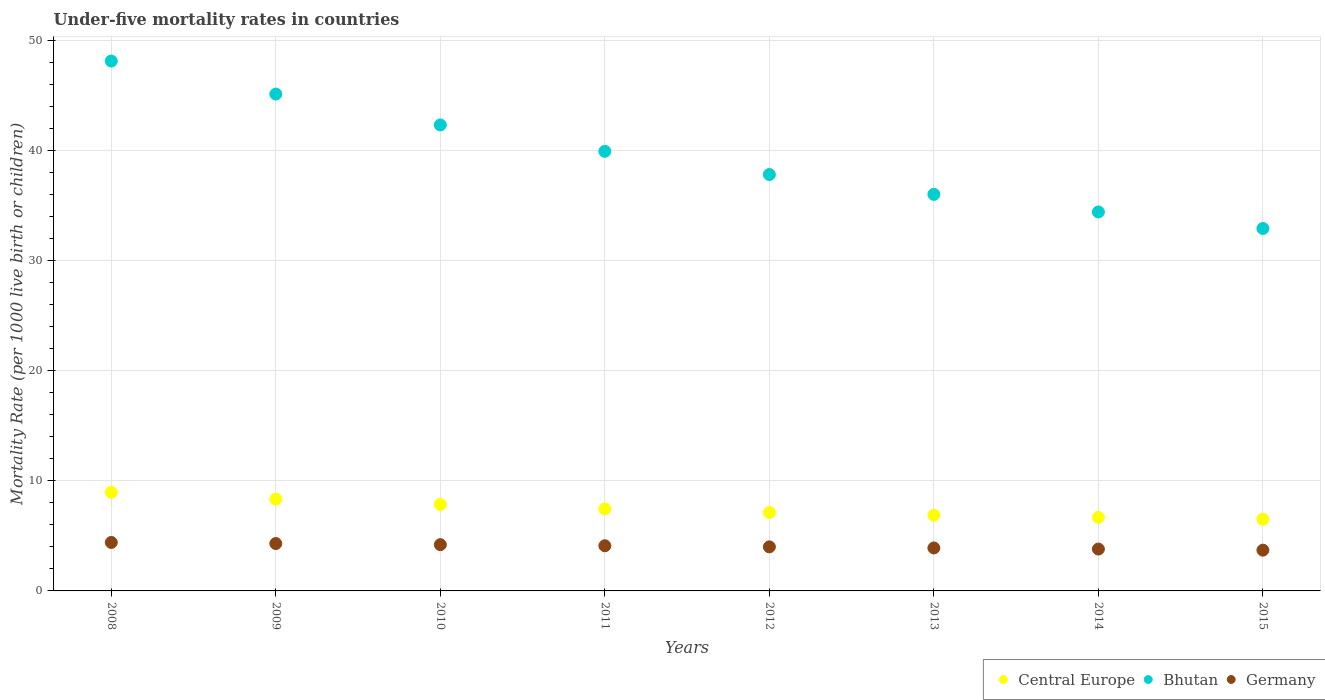Is the number of dotlines equal to the number of legend labels?
Offer a very short reply. Yes. What is the under-five mortality rate in Bhutan in 2012?
Offer a terse response. 37.8. Across all years, what is the maximum under-five mortality rate in Central Europe?
Give a very brief answer. 8.95. Across all years, what is the minimum under-five mortality rate in Central Europe?
Give a very brief answer. 6.51. In which year was the under-five mortality rate in Central Europe minimum?
Ensure brevity in your answer.  2015. What is the total under-five mortality rate in Germany in the graph?
Your response must be concise. 32.4. What is the difference between the under-five mortality rate in Bhutan in 2010 and that in 2014?
Ensure brevity in your answer.  7.9. What is the average under-five mortality rate in Central Europe per year?
Provide a succinct answer. 7.47. In the year 2012, what is the difference between the under-five mortality rate in Central Europe and under-five mortality rate in Bhutan?
Ensure brevity in your answer.  -30.68. In how many years, is the under-five mortality rate in Central Europe greater than 20?
Offer a terse response. 0. What is the ratio of the under-five mortality rate in Central Europe in 2010 to that in 2014?
Your answer should be compact. 1.18. What is the difference between the highest and the lowest under-five mortality rate in Central Europe?
Provide a succinct answer. 2.44. Does the under-five mortality rate in Germany monotonically increase over the years?
Offer a very short reply. No. Is the under-five mortality rate in Bhutan strictly less than the under-five mortality rate in Germany over the years?
Offer a very short reply. No. How many years are there in the graph?
Make the answer very short. 8. Are the values on the major ticks of Y-axis written in scientific E-notation?
Offer a very short reply. No. Does the graph contain any zero values?
Ensure brevity in your answer.  No. Where does the legend appear in the graph?
Your answer should be compact. Bottom right. How many legend labels are there?
Your answer should be compact. 3. What is the title of the graph?
Provide a short and direct response. Under-five mortality rates in countries. What is the label or title of the Y-axis?
Give a very brief answer. Mortality Rate (per 1000 live birth or children). What is the Mortality Rate (per 1000 live birth or children) in Central Europe in 2008?
Offer a very short reply. 8.95. What is the Mortality Rate (per 1000 live birth or children) in Bhutan in 2008?
Provide a succinct answer. 48.1. What is the Mortality Rate (per 1000 live birth or children) in Central Europe in 2009?
Your answer should be compact. 8.34. What is the Mortality Rate (per 1000 live birth or children) of Bhutan in 2009?
Ensure brevity in your answer.  45.1. What is the Mortality Rate (per 1000 live birth or children) in Central Europe in 2010?
Make the answer very short. 7.85. What is the Mortality Rate (per 1000 live birth or children) of Bhutan in 2010?
Offer a very short reply. 42.3. What is the Mortality Rate (per 1000 live birth or children) in Germany in 2010?
Provide a short and direct response. 4.2. What is the Mortality Rate (per 1000 live birth or children) of Central Europe in 2011?
Keep it short and to the point. 7.45. What is the Mortality Rate (per 1000 live birth or children) in Bhutan in 2011?
Provide a succinct answer. 39.9. What is the Mortality Rate (per 1000 live birth or children) in Central Europe in 2012?
Your response must be concise. 7.12. What is the Mortality Rate (per 1000 live birth or children) of Bhutan in 2012?
Offer a very short reply. 37.8. What is the Mortality Rate (per 1000 live birth or children) in Central Europe in 2013?
Provide a succinct answer. 6.88. What is the Mortality Rate (per 1000 live birth or children) in Central Europe in 2014?
Your answer should be very brief. 6.68. What is the Mortality Rate (per 1000 live birth or children) in Bhutan in 2014?
Give a very brief answer. 34.4. What is the Mortality Rate (per 1000 live birth or children) in Central Europe in 2015?
Offer a very short reply. 6.51. What is the Mortality Rate (per 1000 live birth or children) in Bhutan in 2015?
Offer a very short reply. 32.9. What is the Mortality Rate (per 1000 live birth or children) of Germany in 2015?
Ensure brevity in your answer.  3.7. Across all years, what is the maximum Mortality Rate (per 1000 live birth or children) of Central Europe?
Make the answer very short. 8.95. Across all years, what is the maximum Mortality Rate (per 1000 live birth or children) of Bhutan?
Keep it short and to the point. 48.1. Across all years, what is the minimum Mortality Rate (per 1000 live birth or children) in Central Europe?
Make the answer very short. 6.51. Across all years, what is the minimum Mortality Rate (per 1000 live birth or children) in Bhutan?
Offer a very short reply. 32.9. Across all years, what is the minimum Mortality Rate (per 1000 live birth or children) of Germany?
Your answer should be compact. 3.7. What is the total Mortality Rate (per 1000 live birth or children) in Central Europe in the graph?
Ensure brevity in your answer.  59.76. What is the total Mortality Rate (per 1000 live birth or children) of Bhutan in the graph?
Offer a terse response. 316.5. What is the total Mortality Rate (per 1000 live birth or children) of Germany in the graph?
Your response must be concise. 32.4. What is the difference between the Mortality Rate (per 1000 live birth or children) in Central Europe in 2008 and that in 2009?
Keep it short and to the point. 0.61. What is the difference between the Mortality Rate (per 1000 live birth or children) of Bhutan in 2008 and that in 2009?
Keep it short and to the point. 3. What is the difference between the Mortality Rate (per 1000 live birth or children) in Germany in 2008 and that in 2009?
Ensure brevity in your answer.  0.1. What is the difference between the Mortality Rate (per 1000 live birth or children) of Central Europe in 2008 and that in 2010?
Offer a very short reply. 1.1. What is the difference between the Mortality Rate (per 1000 live birth or children) of Bhutan in 2008 and that in 2010?
Provide a short and direct response. 5.8. What is the difference between the Mortality Rate (per 1000 live birth or children) in Germany in 2008 and that in 2010?
Give a very brief answer. 0.2. What is the difference between the Mortality Rate (per 1000 live birth or children) of Central Europe in 2008 and that in 2011?
Provide a short and direct response. 1.5. What is the difference between the Mortality Rate (per 1000 live birth or children) in Bhutan in 2008 and that in 2011?
Give a very brief answer. 8.2. What is the difference between the Mortality Rate (per 1000 live birth or children) of Germany in 2008 and that in 2011?
Offer a very short reply. 0.3. What is the difference between the Mortality Rate (per 1000 live birth or children) in Central Europe in 2008 and that in 2012?
Offer a very short reply. 1.83. What is the difference between the Mortality Rate (per 1000 live birth or children) in Germany in 2008 and that in 2012?
Your response must be concise. 0.4. What is the difference between the Mortality Rate (per 1000 live birth or children) of Central Europe in 2008 and that in 2013?
Offer a terse response. 2.07. What is the difference between the Mortality Rate (per 1000 live birth or children) in Bhutan in 2008 and that in 2013?
Your answer should be very brief. 12.1. What is the difference between the Mortality Rate (per 1000 live birth or children) in Germany in 2008 and that in 2013?
Your answer should be compact. 0.5. What is the difference between the Mortality Rate (per 1000 live birth or children) in Central Europe in 2008 and that in 2014?
Your response must be concise. 2.27. What is the difference between the Mortality Rate (per 1000 live birth or children) in Bhutan in 2008 and that in 2014?
Offer a very short reply. 13.7. What is the difference between the Mortality Rate (per 1000 live birth or children) in Central Europe in 2008 and that in 2015?
Provide a short and direct response. 2.44. What is the difference between the Mortality Rate (per 1000 live birth or children) in Germany in 2008 and that in 2015?
Your answer should be very brief. 0.7. What is the difference between the Mortality Rate (per 1000 live birth or children) in Central Europe in 2009 and that in 2010?
Provide a short and direct response. 0.49. What is the difference between the Mortality Rate (per 1000 live birth or children) of Central Europe in 2009 and that in 2011?
Give a very brief answer. 0.89. What is the difference between the Mortality Rate (per 1000 live birth or children) of Central Europe in 2009 and that in 2012?
Provide a short and direct response. 1.22. What is the difference between the Mortality Rate (per 1000 live birth or children) of Bhutan in 2009 and that in 2012?
Provide a succinct answer. 7.3. What is the difference between the Mortality Rate (per 1000 live birth or children) in Germany in 2009 and that in 2012?
Ensure brevity in your answer.  0.3. What is the difference between the Mortality Rate (per 1000 live birth or children) of Central Europe in 2009 and that in 2013?
Your answer should be very brief. 1.46. What is the difference between the Mortality Rate (per 1000 live birth or children) of Central Europe in 2009 and that in 2014?
Offer a very short reply. 1.66. What is the difference between the Mortality Rate (per 1000 live birth or children) in Bhutan in 2009 and that in 2014?
Offer a very short reply. 10.7. What is the difference between the Mortality Rate (per 1000 live birth or children) of Germany in 2009 and that in 2014?
Offer a terse response. 0.5. What is the difference between the Mortality Rate (per 1000 live birth or children) of Central Europe in 2009 and that in 2015?
Keep it short and to the point. 1.83. What is the difference between the Mortality Rate (per 1000 live birth or children) of Bhutan in 2009 and that in 2015?
Offer a very short reply. 12.2. What is the difference between the Mortality Rate (per 1000 live birth or children) of Germany in 2009 and that in 2015?
Make the answer very short. 0.6. What is the difference between the Mortality Rate (per 1000 live birth or children) of Central Europe in 2010 and that in 2011?
Ensure brevity in your answer.  0.4. What is the difference between the Mortality Rate (per 1000 live birth or children) in Bhutan in 2010 and that in 2011?
Offer a very short reply. 2.4. What is the difference between the Mortality Rate (per 1000 live birth or children) of Germany in 2010 and that in 2011?
Provide a succinct answer. 0.1. What is the difference between the Mortality Rate (per 1000 live birth or children) of Central Europe in 2010 and that in 2012?
Your response must be concise. 0.73. What is the difference between the Mortality Rate (per 1000 live birth or children) in Bhutan in 2010 and that in 2012?
Ensure brevity in your answer.  4.5. What is the difference between the Mortality Rate (per 1000 live birth or children) in Bhutan in 2010 and that in 2013?
Your answer should be very brief. 6.3. What is the difference between the Mortality Rate (per 1000 live birth or children) in Central Europe in 2010 and that in 2014?
Ensure brevity in your answer.  1.17. What is the difference between the Mortality Rate (per 1000 live birth or children) of Central Europe in 2010 and that in 2015?
Your answer should be very brief. 1.34. What is the difference between the Mortality Rate (per 1000 live birth or children) of Bhutan in 2010 and that in 2015?
Give a very brief answer. 9.4. What is the difference between the Mortality Rate (per 1000 live birth or children) in Central Europe in 2011 and that in 2012?
Offer a very short reply. 0.33. What is the difference between the Mortality Rate (per 1000 live birth or children) in Bhutan in 2011 and that in 2012?
Offer a terse response. 2.1. What is the difference between the Mortality Rate (per 1000 live birth or children) in Germany in 2011 and that in 2012?
Offer a terse response. 0.1. What is the difference between the Mortality Rate (per 1000 live birth or children) of Central Europe in 2011 and that in 2013?
Keep it short and to the point. 0.57. What is the difference between the Mortality Rate (per 1000 live birth or children) in Bhutan in 2011 and that in 2013?
Offer a terse response. 3.9. What is the difference between the Mortality Rate (per 1000 live birth or children) in Central Europe in 2011 and that in 2014?
Offer a very short reply. 0.77. What is the difference between the Mortality Rate (per 1000 live birth or children) of Germany in 2011 and that in 2014?
Keep it short and to the point. 0.3. What is the difference between the Mortality Rate (per 1000 live birth or children) in Central Europe in 2011 and that in 2015?
Offer a terse response. 0.94. What is the difference between the Mortality Rate (per 1000 live birth or children) in Germany in 2011 and that in 2015?
Give a very brief answer. 0.4. What is the difference between the Mortality Rate (per 1000 live birth or children) in Central Europe in 2012 and that in 2013?
Provide a short and direct response. 0.24. What is the difference between the Mortality Rate (per 1000 live birth or children) of Bhutan in 2012 and that in 2013?
Make the answer very short. 1.8. What is the difference between the Mortality Rate (per 1000 live birth or children) of Germany in 2012 and that in 2013?
Offer a very short reply. 0.1. What is the difference between the Mortality Rate (per 1000 live birth or children) of Central Europe in 2012 and that in 2014?
Your answer should be compact. 0.44. What is the difference between the Mortality Rate (per 1000 live birth or children) of Germany in 2012 and that in 2014?
Make the answer very short. 0.2. What is the difference between the Mortality Rate (per 1000 live birth or children) in Central Europe in 2012 and that in 2015?
Keep it short and to the point. 0.61. What is the difference between the Mortality Rate (per 1000 live birth or children) of Bhutan in 2012 and that in 2015?
Keep it short and to the point. 4.9. What is the difference between the Mortality Rate (per 1000 live birth or children) of Central Europe in 2013 and that in 2014?
Keep it short and to the point. 0.2. What is the difference between the Mortality Rate (per 1000 live birth or children) of Bhutan in 2013 and that in 2014?
Ensure brevity in your answer.  1.6. What is the difference between the Mortality Rate (per 1000 live birth or children) of Central Europe in 2013 and that in 2015?
Make the answer very short. 0.37. What is the difference between the Mortality Rate (per 1000 live birth or children) in Bhutan in 2013 and that in 2015?
Your answer should be very brief. 3.1. What is the difference between the Mortality Rate (per 1000 live birth or children) of Central Europe in 2014 and that in 2015?
Ensure brevity in your answer.  0.17. What is the difference between the Mortality Rate (per 1000 live birth or children) in Central Europe in 2008 and the Mortality Rate (per 1000 live birth or children) in Bhutan in 2009?
Offer a very short reply. -36.15. What is the difference between the Mortality Rate (per 1000 live birth or children) of Central Europe in 2008 and the Mortality Rate (per 1000 live birth or children) of Germany in 2009?
Ensure brevity in your answer.  4.65. What is the difference between the Mortality Rate (per 1000 live birth or children) of Bhutan in 2008 and the Mortality Rate (per 1000 live birth or children) of Germany in 2009?
Give a very brief answer. 43.8. What is the difference between the Mortality Rate (per 1000 live birth or children) in Central Europe in 2008 and the Mortality Rate (per 1000 live birth or children) in Bhutan in 2010?
Offer a very short reply. -33.35. What is the difference between the Mortality Rate (per 1000 live birth or children) in Central Europe in 2008 and the Mortality Rate (per 1000 live birth or children) in Germany in 2010?
Provide a short and direct response. 4.75. What is the difference between the Mortality Rate (per 1000 live birth or children) of Bhutan in 2008 and the Mortality Rate (per 1000 live birth or children) of Germany in 2010?
Provide a succinct answer. 43.9. What is the difference between the Mortality Rate (per 1000 live birth or children) of Central Europe in 2008 and the Mortality Rate (per 1000 live birth or children) of Bhutan in 2011?
Your answer should be very brief. -30.95. What is the difference between the Mortality Rate (per 1000 live birth or children) in Central Europe in 2008 and the Mortality Rate (per 1000 live birth or children) in Germany in 2011?
Ensure brevity in your answer.  4.85. What is the difference between the Mortality Rate (per 1000 live birth or children) in Bhutan in 2008 and the Mortality Rate (per 1000 live birth or children) in Germany in 2011?
Your response must be concise. 44. What is the difference between the Mortality Rate (per 1000 live birth or children) of Central Europe in 2008 and the Mortality Rate (per 1000 live birth or children) of Bhutan in 2012?
Give a very brief answer. -28.85. What is the difference between the Mortality Rate (per 1000 live birth or children) in Central Europe in 2008 and the Mortality Rate (per 1000 live birth or children) in Germany in 2012?
Provide a short and direct response. 4.95. What is the difference between the Mortality Rate (per 1000 live birth or children) of Bhutan in 2008 and the Mortality Rate (per 1000 live birth or children) of Germany in 2012?
Make the answer very short. 44.1. What is the difference between the Mortality Rate (per 1000 live birth or children) in Central Europe in 2008 and the Mortality Rate (per 1000 live birth or children) in Bhutan in 2013?
Provide a short and direct response. -27.05. What is the difference between the Mortality Rate (per 1000 live birth or children) in Central Europe in 2008 and the Mortality Rate (per 1000 live birth or children) in Germany in 2013?
Your answer should be compact. 5.05. What is the difference between the Mortality Rate (per 1000 live birth or children) in Bhutan in 2008 and the Mortality Rate (per 1000 live birth or children) in Germany in 2013?
Your answer should be very brief. 44.2. What is the difference between the Mortality Rate (per 1000 live birth or children) of Central Europe in 2008 and the Mortality Rate (per 1000 live birth or children) of Bhutan in 2014?
Offer a terse response. -25.45. What is the difference between the Mortality Rate (per 1000 live birth or children) of Central Europe in 2008 and the Mortality Rate (per 1000 live birth or children) of Germany in 2014?
Your answer should be compact. 5.15. What is the difference between the Mortality Rate (per 1000 live birth or children) in Bhutan in 2008 and the Mortality Rate (per 1000 live birth or children) in Germany in 2014?
Provide a succinct answer. 44.3. What is the difference between the Mortality Rate (per 1000 live birth or children) in Central Europe in 2008 and the Mortality Rate (per 1000 live birth or children) in Bhutan in 2015?
Provide a short and direct response. -23.95. What is the difference between the Mortality Rate (per 1000 live birth or children) of Central Europe in 2008 and the Mortality Rate (per 1000 live birth or children) of Germany in 2015?
Your answer should be very brief. 5.25. What is the difference between the Mortality Rate (per 1000 live birth or children) in Bhutan in 2008 and the Mortality Rate (per 1000 live birth or children) in Germany in 2015?
Make the answer very short. 44.4. What is the difference between the Mortality Rate (per 1000 live birth or children) of Central Europe in 2009 and the Mortality Rate (per 1000 live birth or children) of Bhutan in 2010?
Your answer should be very brief. -33.96. What is the difference between the Mortality Rate (per 1000 live birth or children) of Central Europe in 2009 and the Mortality Rate (per 1000 live birth or children) of Germany in 2010?
Your response must be concise. 4.14. What is the difference between the Mortality Rate (per 1000 live birth or children) in Bhutan in 2009 and the Mortality Rate (per 1000 live birth or children) in Germany in 2010?
Provide a succinct answer. 40.9. What is the difference between the Mortality Rate (per 1000 live birth or children) of Central Europe in 2009 and the Mortality Rate (per 1000 live birth or children) of Bhutan in 2011?
Your response must be concise. -31.56. What is the difference between the Mortality Rate (per 1000 live birth or children) of Central Europe in 2009 and the Mortality Rate (per 1000 live birth or children) of Germany in 2011?
Your answer should be very brief. 4.24. What is the difference between the Mortality Rate (per 1000 live birth or children) in Central Europe in 2009 and the Mortality Rate (per 1000 live birth or children) in Bhutan in 2012?
Ensure brevity in your answer.  -29.46. What is the difference between the Mortality Rate (per 1000 live birth or children) in Central Europe in 2009 and the Mortality Rate (per 1000 live birth or children) in Germany in 2012?
Your response must be concise. 4.34. What is the difference between the Mortality Rate (per 1000 live birth or children) of Bhutan in 2009 and the Mortality Rate (per 1000 live birth or children) of Germany in 2012?
Ensure brevity in your answer.  41.1. What is the difference between the Mortality Rate (per 1000 live birth or children) in Central Europe in 2009 and the Mortality Rate (per 1000 live birth or children) in Bhutan in 2013?
Your answer should be compact. -27.66. What is the difference between the Mortality Rate (per 1000 live birth or children) in Central Europe in 2009 and the Mortality Rate (per 1000 live birth or children) in Germany in 2013?
Keep it short and to the point. 4.44. What is the difference between the Mortality Rate (per 1000 live birth or children) of Bhutan in 2009 and the Mortality Rate (per 1000 live birth or children) of Germany in 2013?
Ensure brevity in your answer.  41.2. What is the difference between the Mortality Rate (per 1000 live birth or children) of Central Europe in 2009 and the Mortality Rate (per 1000 live birth or children) of Bhutan in 2014?
Your answer should be compact. -26.06. What is the difference between the Mortality Rate (per 1000 live birth or children) in Central Europe in 2009 and the Mortality Rate (per 1000 live birth or children) in Germany in 2014?
Ensure brevity in your answer.  4.54. What is the difference between the Mortality Rate (per 1000 live birth or children) of Bhutan in 2009 and the Mortality Rate (per 1000 live birth or children) of Germany in 2014?
Offer a very short reply. 41.3. What is the difference between the Mortality Rate (per 1000 live birth or children) in Central Europe in 2009 and the Mortality Rate (per 1000 live birth or children) in Bhutan in 2015?
Provide a short and direct response. -24.56. What is the difference between the Mortality Rate (per 1000 live birth or children) in Central Europe in 2009 and the Mortality Rate (per 1000 live birth or children) in Germany in 2015?
Your response must be concise. 4.64. What is the difference between the Mortality Rate (per 1000 live birth or children) of Bhutan in 2009 and the Mortality Rate (per 1000 live birth or children) of Germany in 2015?
Your answer should be compact. 41.4. What is the difference between the Mortality Rate (per 1000 live birth or children) of Central Europe in 2010 and the Mortality Rate (per 1000 live birth or children) of Bhutan in 2011?
Offer a very short reply. -32.05. What is the difference between the Mortality Rate (per 1000 live birth or children) in Central Europe in 2010 and the Mortality Rate (per 1000 live birth or children) in Germany in 2011?
Ensure brevity in your answer.  3.75. What is the difference between the Mortality Rate (per 1000 live birth or children) in Bhutan in 2010 and the Mortality Rate (per 1000 live birth or children) in Germany in 2011?
Your answer should be very brief. 38.2. What is the difference between the Mortality Rate (per 1000 live birth or children) of Central Europe in 2010 and the Mortality Rate (per 1000 live birth or children) of Bhutan in 2012?
Your response must be concise. -29.95. What is the difference between the Mortality Rate (per 1000 live birth or children) in Central Europe in 2010 and the Mortality Rate (per 1000 live birth or children) in Germany in 2012?
Offer a terse response. 3.85. What is the difference between the Mortality Rate (per 1000 live birth or children) in Bhutan in 2010 and the Mortality Rate (per 1000 live birth or children) in Germany in 2012?
Keep it short and to the point. 38.3. What is the difference between the Mortality Rate (per 1000 live birth or children) of Central Europe in 2010 and the Mortality Rate (per 1000 live birth or children) of Bhutan in 2013?
Your response must be concise. -28.15. What is the difference between the Mortality Rate (per 1000 live birth or children) in Central Europe in 2010 and the Mortality Rate (per 1000 live birth or children) in Germany in 2013?
Give a very brief answer. 3.95. What is the difference between the Mortality Rate (per 1000 live birth or children) in Bhutan in 2010 and the Mortality Rate (per 1000 live birth or children) in Germany in 2013?
Give a very brief answer. 38.4. What is the difference between the Mortality Rate (per 1000 live birth or children) of Central Europe in 2010 and the Mortality Rate (per 1000 live birth or children) of Bhutan in 2014?
Provide a succinct answer. -26.55. What is the difference between the Mortality Rate (per 1000 live birth or children) in Central Europe in 2010 and the Mortality Rate (per 1000 live birth or children) in Germany in 2014?
Offer a very short reply. 4.05. What is the difference between the Mortality Rate (per 1000 live birth or children) in Bhutan in 2010 and the Mortality Rate (per 1000 live birth or children) in Germany in 2014?
Offer a terse response. 38.5. What is the difference between the Mortality Rate (per 1000 live birth or children) in Central Europe in 2010 and the Mortality Rate (per 1000 live birth or children) in Bhutan in 2015?
Provide a succinct answer. -25.05. What is the difference between the Mortality Rate (per 1000 live birth or children) of Central Europe in 2010 and the Mortality Rate (per 1000 live birth or children) of Germany in 2015?
Keep it short and to the point. 4.15. What is the difference between the Mortality Rate (per 1000 live birth or children) of Bhutan in 2010 and the Mortality Rate (per 1000 live birth or children) of Germany in 2015?
Your response must be concise. 38.6. What is the difference between the Mortality Rate (per 1000 live birth or children) in Central Europe in 2011 and the Mortality Rate (per 1000 live birth or children) in Bhutan in 2012?
Offer a very short reply. -30.35. What is the difference between the Mortality Rate (per 1000 live birth or children) in Central Europe in 2011 and the Mortality Rate (per 1000 live birth or children) in Germany in 2012?
Offer a terse response. 3.45. What is the difference between the Mortality Rate (per 1000 live birth or children) of Bhutan in 2011 and the Mortality Rate (per 1000 live birth or children) of Germany in 2012?
Keep it short and to the point. 35.9. What is the difference between the Mortality Rate (per 1000 live birth or children) of Central Europe in 2011 and the Mortality Rate (per 1000 live birth or children) of Bhutan in 2013?
Your answer should be very brief. -28.55. What is the difference between the Mortality Rate (per 1000 live birth or children) in Central Europe in 2011 and the Mortality Rate (per 1000 live birth or children) in Germany in 2013?
Provide a succinct answer. 3.55. What is the difference between the Mortality Rate (per 1000 live birth or children) of Central Europe in 2011 and the Mortality Rate (per 1000 live birth or children) of Bhutan in 2014?
Make the answer very short. -26.95. What is the difference between the Mortality Rate (per 1000 live birth or children) in Central Europe in 2011 and the Mortality Rate (per 1000 live birth or children) in Germany in 2014?
Offer a terse response. 3.65. What is the difference between the Mortality Rate (per 1000 live birth or children) in Bhutan in 2011 and the Mortality Rate (per 1000 live birth or children) in Germany in 2014?
Offer a terse response. 36.1. What is the difference between the Mortality Rate (per 1000 live birth or children) of Central Europe in 2011 and the Mortality Rate (per 1000 live birth or children) of Bhutan in 2015?
Keep it short and to the point. -25.45. What is the difference between the Mortality Rate (per 1000 live birth or children) of Central Europe in 2011 and the Mortality Rate (per 1000 live birth or children) of Germany in 2015?
Ensure brevity in your answer.  3.75. What is the difference between the Mortality Rate (per 1000 live birth or children) in Bhutan in 2011 and the Mortality Rate (per 1000 live birth or children) in Germany in 2015?
Give a very brief answer. 36.2. What is the difference between the Mortality Rate (per 1000 live birth or children) of Central Europe in 2012 and the Mortality Rate (per 1000 live birth or children) of Bhutan in 2013?
Give a very brief answer. -28.88. What is the difference between the Mortality Rate (per 1000 live birth or children) in Central Europe in 2012 and the Mortality Rate (per 1000 live birth or children) in Germany in 2013?
Your response must be concise. 3.22. What is the difference between the Mortality Rate (per 1000 live birth or children) of Bhutan in 2012 and the Mortality Rate (per 1000 live birth or children) of Germany in 2013?
Your response must be concise. 33.9. What is the difference between the Mortality Rate (per 1000 live birth or children) of Central Europe in 2012 and the Mortality Rate (per 1000 live birth or children) of Bhutan in 2014?
Your answer should be compact. -27.28. What is the difference between the Mortality Rate (per 1000 live birth or children) of Central Europe in 2012 and the Mortality Rate (per 1000 live birth or children) of Germany in 2014?
Make the answer very short. 3.32. What is the difference between the Mortality Rate (per 1000 live birth or children) in Bhutan in 2012 and the Mortality Rate (per 1000 live birth or children) in Germany in 2014?
Your answer should be compact. 34. What is the difference between the Mortality Rate (per 1000 live birth or children) of Central Europe in 2012 and the Mortality Rate (per 1000 live birth or children) of Bhutan in 2015?
Your answer should be compact. -25.78. What is the difference between the Mortality Rate (per 1000 live birth or children) in Central Europe in 2012 and the Mortality Rate (per 1000 live birth or children) in Germany in 2015?
Ensure brevity in your answer.  3.42. What is the difference between the Mortality Rate (per 1000 live birth or children) in Bhutan in 2012 and the Mortality Rate (per 1000 live birth or children) in Germany in 2015?
Your answer should be very brief. 34.1. What is the difference between the Mortality Rate (per 1000 live birth or children) of Central Europe in 2013 and the Mortality Rate (per 1000 live birth or children) of Bhutan in 2014?
Your answer should be very brief. -27.52. What is the difference between the Mortality Rate (per 1000 live birth or children) of Central Europe in 2013 and the Mortality Rate (per 1000 live birth or children) of Germany in 2014?
Your answer should be compact. 3.08. What is the difference between the Mortality Rate (per 1000 live birth or children) of Bhutan in 2013 and the Mortality Rate (per 1000 live birth or children) of Germany in 2014?
Your answer should be very brief. 32.2. What is the difference between the Mortality Rate (per 1000 live birth or children) in Central Europe in 2013 and the Mortality Rate (per 1000 live birth or children) in Bhutan in 2015?
Keep it short and to the point. -26.02. What is the difference between the Mortality Rate (per 1000 live birth or children) in Central Europe in 2013 and the Mortality Rate (per 1000 live birth or children) in Germany in 2015?
Your answer should be very brief. 3.18. What is the difference between the Mortality Rate (per 1000 live birth or children) of Bhutan in 2013 and the Mortality Rate (per 1000 live birth or children) of Germany in 2015?
Offer a terse response. 32.3. What is the difference between the Mortality Rate (per 1000 live birth or children) of Central Europe in 2014 and the Mortality Rate (per 1000 live birth or children) of Bhutan in 2015?
Keep it short and to the point. -26.22. What is the difference between the Mortality Rate (per 1000 live birth or children) in Central Europe in 2014 and the Mortality Rate (per 1000 live birth or children) in Germany in 2015?
Ensure brevity in your answer.  2.98. What is the difference between the Mortality Rate (per 1000 live birth or children) of Bhutan in 2014 and the Mortality Rate (per 1000 live birth or children) of Germany in 2015?
Your answer should be compact. 30.7. What is the average Mortality Rate (per 1000 live birth or children) in Central Europe per year?
Provide a short and direct response. 7.47. What is the average Mortality Rate (per 1000 live birth or children) in Bhutan per year?
Offer a terse response. 39.56. What is the average Mortality Rate (per 1000 live birth or children) of Germany per year?
Ensure brevity in your answer.  4.05. In the year 2008, what is the difference between the Mortality Rate (per 1000 live birth or children) of Central Europe and Mortality Rate (per 1000 live birth or children) of Bhutan?
Offer a very short reply. -39.15. In the year 2008, what is the difference between the Mortality Rate (per 1000 live birth or children) of Central Europe and Mortality Rate (per 1000 live birth or children) of Germany?
Your response must be concise. 4.55. In the year 2008, what is the difference between the Mortality Rate (per 1000 live birth or children) in Bhutan and Mortality Rate (per 1000 live birth or children) in Germany?
Offer a very short reply. 43.7. In the year 2009, what is the difference between the Mortality Rate (per 1000 live birth or children) of Central Europe and Mortality Rate (per 1000 live birth or children) of Bhutan?
Provide a succinct answer. -36.76. In the year 2009, what is the difference between the Mortality Rate (per 1000 live birth or children) of Central Europe and Mortality Rate (per 1000 live birth or children) of Germany?
Provide a short and direct response. 4.04. In the year 2009, what is the difference between the Mortality Rate (per 1000 live birth or children) in Bhutan and Mortality Rate (per 1000 live birth or children) in Germany?
Your answer should be very brief. 40.8. In the year 2010, what is the difference between the Mortality Rate (per 1000 live birth or children) of Central Europe and Mortality Rate (per 1000 live birth or children) of Bhutan?
Make the answer very short. -34.45. In the year 2010, what is the difference between the Mortality Rate (per 1000 live birth or children) of Central Europe and Mortality Rate (per 1000 live birth or children) of Germany?
Provide a succinct answer. 3.65. In the year 2010, what is the difference between the Mortality Rate (per 1000 live birth or children) in Bhutan and Mortality Rate (per 1000 live birth or children) in Germany?
Keep it short and to the point. 38.1. In the year 2011, what is the difference between the Mortality Rate (per 1000 live birth or children) of Central Europe and Mortality Rate (per 1000 live birth or children) of Bhutan?
Ensure brevity in your answer.  -32.45. In the year 2011, what is the difference between the Mortality Rate (per 1000 live birth or children) in Central Europe and Mortality Rate (per 1000 live birth or children) in Germany?
Offer a very short reply. 3.35. In the year 2011, what is the difference between the Mortality Rate (per 1000 live birth or children) in Bhutan and Mortality Rate (per 1000 live birth or children) in Germany?
Provide a succinct answer. 35.8. In the year 2012, what is the difference between the Mortality Rate (per 1000 live birth or children) in Central Europe and Mortality Rate (per 1000 live birth or children) in Bhutan?
Offer a very short reply. -30.68. In the year 2012, what is the difference between the Mortality Rate (per 1000 live birth or children) of Central Europe and Mortality Rate (per 1000 live birth or children) of Germany?
Make the answer very short. 3.12. In the year 2012, what is the difference between the Mortality Rate (per 1000 live birth or children) of Bhutan and Mortality Rate (per 1000 live birth or children) of Germany?
Provide a short and direct response. 33.8. In the year 2013, what is the difference between the Mortality Rate (per 1000 live birth or children) in Central Europe and Mortality Rate (per 1000 live birth or children) in Bhutan?
Offer a terse response. -29.12. In the year 2013, what is the difference between the Mortality Rate (per 1000 live birth or children) in Central Europe and Mortality Rate (per 1000 live birth or children) in Germany?
Provide a short and direct response. 2.98. In the year 2013, what is the difference between the Mortality Rate (per 1000 live birth or children) in Bhutan and Mortality Rate (per 1000 live birth or children) in Germany?
Your answer should be compact. 32.1. In the year 2014, what is the difference between the Mortality Rate (per 1000 live birth or children) of Central Europe and Mortality Rate (per 1000 live birth or children) of Bhutan?
Your answer should be very brief. -27.72. In the year 2014, what is the difference between the Mortality Rate (per 1000 live birth or children) in Central Europe and Mortality Rate (per 1000 live birth or children) in Germany?
Keep it short and to the point. 2.88. In the year 2014, what is the difference between the Mortality Rate (per 1000 live birth or children) of Bhutan and Mortality Rate (per 1000 live birth or children) of Germany?
Provide a short and direct response. 30.6. In the year 2015, what is the difference between the Mortality Rate (per 1000 live birth or children) of Central Europe and Mortality Rate (per 1000 live birth or children) of Bhutan?
Ensure brevity in your answer.  -26.39. In the year 2015, what is the difference between the Mortality Rate (per 1000 live birth or children) of Central Europe and Mortality Rate (per 1000 live birth or children) of Germany?
Provide a succinct answer. 2.81. In the year 2015, what is the difference between the Mortality Rate (per 1000 live birth or children) of Bhutan and Mortality Rate (per 1000 live birth or children) of Germany?
Keep it short and to the point. 29.2. What is the ratio of the Mortality Rate (per 1000 live birth or children) in Central Europe in 2008 to that in 2009?
Offer a terse response. 1.07. What is the ratio of the Mortality Rate (per 1000 live birth or children) of Bhutan in 2008 to that in 2009?
Make the answer very short. 1.07. What is the ratio of the Mortality Rate (per 1000 live birth or children) of Germany in 2008 to that in 2009?
Your answer should be compact. 1.02. What is the ratio of the Mortality Rate (per 1000 live birth or children) in Central Europe in 2008 to that in 2010?
Your answer should be compact. 1.14. What is the ratio of the Mortality Rate (per 1000 live birth or children) in Bhutan in 2008 to that in 2010?
Provide a short and direct response. 1.14. What is the ratio of the Mortality Rate (per 1000 live birth or children) of Germany in 2008 to that in 2010?
Ensure brevity in your answer.  1.05. What is the ratio of the Mortality Rate (per 1000 live birth or children) in Central Europe in 2008 to that in 2011?
Offer a terse response. 1.2. What is the ratio of the Mortality Rate (per 1000 live birth or children) of Bhutan in 2008 to that in 2011?
Provide a short and direct response. 1.21. What is the ratio of the Mortality Rate (per 1000 live birth or children) in Germany in 2008 to that in 2011?
Give a very brief answer. 1.07. What is the ratio of the Mortality Rate (per 1000 live birth or children) of Central Europe in 2008 to that in 2012?
Give a very brief answer. 1.26. What is the ratio of the Mortality Rate (per 1000 live birth or children) in Bhutan in 2008 to that in 2012?
Your response must be concise. 1.27. What is the ratio of the Mortality Rate (per 1000 live birth or children) of Germany in 2008 to that in 2012?
Your answer should be compact. 1.1. What is the ratio of the Mortality Rate (per 1000 live birth or children) in Central Europe in 2008 to that in 2013?
Provide a succinct answer. 1.3. What is the ratio of the Mortality Rate (per 1000 live birth or children) of Bhutan in 2008 to that in 2013?
Offer a terse response. 1.34. What is the ratio of the Mortality Rate (per 1000 live birth or children) of Germany in 2008 to that in 2013?
Give a very brief answer. 1.13. What is the ratio of the Mortality Rate (per 1000 live birth or children) of Central Europe in 2008 to that in 2014?
Your response must be concise. 1.34. What is the ratio of the Mortality Rate (per 1000 live birth or children) in Bhutan in 2008 to that in 2014?
Ensure brevity in your answer.  1.4. What is the ratio of the Mortality Rate (per 1000 live birth or children) in Germany in 2008 to that in 2014?
Your answer should be very brief. 1.16. What is the ratio of the Mortality Rate (per 1000 live birth or children) of Central Europe in 2008 to that in 2015?
Your answer should be compact. 1.38. What is the ratio of the Mortality Rate (per 1000 live birth or children) in Bhutan in 2008 to that in 2015?
Your response must be concise. 1.46. What is the ratio of the Mortality Rate (per 1000 live birth or children) of Germany in 2008 to that in 2015?
Provide a succinct answer. 1.19. What is the ratio of the Mortality Rate (per 1000 live birth or children) in Central Europe in 2009 to that in 2010?
Provide a succinct answer. 1.06. What is the ratio of the Mortality Rate (per 1000 live birth or children) of Bhutan in 2009 to that in 2010?
Your answer should be compact. 1.07. What is the ratio of the Mortality Rate (per 1000 live birth or children) of Germany in 2009 to that in 2010?
Your answer should be compact. 1.02. What is the ratio of the Mortality Rate (per 1000 live birth or children) of Central Europe in 2009 to that in 2011?
Give a very brief answer. 1.12. What is the ratio of the Mortality Rate (per 1000 live birth or children) of Bhutan in 2009 to that in 2011?
Keep it short and to the point. 1.13. What is the ratio of the Mortality Rate (per 1000 live birth or children) in Germany in 2009 to that in 2011?
Your answer should be very brief. 1.05. What is the ratio of the Mortality Rate (per 1000 live birth or children) in Central Europe in 2009 to that in 2012?
Offer a terse response. 1.17. What is the ratio of the Mortality Rate (per 1000 live birth or children) of Bhutan in 2009 to that in 2012?
Give a very brief answer. 1.19. What is the ratio of the Mortality Rate (per 1000 live birth or children) of Germany in 2009 to that in 2012?
Give a very brief answer. 1.07. What is the ratio of the Mortality Rate (per 1000 live birth or children) of Central Europe in 2009 to that in 2013?
Your response must be concise. 1.21. What is the ratio of the Mortality Rate (per 1000 live birth or children) in Bhutan in 2009 to that in 2013?
Ensure brevity in your answer.  1.25. What is the ratio of the Mortality Rate (per 1000 live birth or children) of Germany in 2009 to that in 2013?
Your answer should be very brief. 1.1. What is the ratio of the Mortality Rate (per 1000 live birth or children) of Central Europe in 2009 to that in 2014?
Make the answer very short. 1.25. What is the ratio of the Mortality Rate (per 1000 live birth or children) of Bhutan in 2009 to that in 2014?
Give a very brief answer. 1.31. What is the ratio of the Mortality Rate (per 1000 live birth or children) in Germany in 2009 to that in 2014?
Ensure brevity in your answer.  1.13. What is the ratio of the Mortality Rate (per 1000 live birth or children) in Central Europe in 2009 to that in 2015?
Your answer should be very brief. 1.28. What is the ratio of the Mortality Rate (per 1000 live birth or children) of Bhutan in 2009 to that in 2015?
Offer a very short reply. 1.37. What is the ratio of the Mortality Rate (per 1000 live birth or children) in Germany in 2009 to that in 2015?
Keep it short and to the point. 1.16. What is the ratio of the Mortality Rate (per 1000 live birth or children) in Central Europe in 2010 to that in 2011?
Your answer should be compact. 1.05. What is the ratio of the Mortality Rate (per 1000 live birth or children) in Bhutan in 2010 to that in 2011?
Your answer should be very brief. 1.06. What is the ratio of the Mortality Rate (per 1000 live birth or children) of Germany in 2010 to that in 2011?
Your answer should be compact. 1.02. What is the ratio of the Mortality Rate (per 1000 live birth or children) in Central Europe in 2010 to that in 2012?
Provide a short and direct response. 1.1. What is the ratio of the Mortality Rate (per 1000 live birth or children) of Bhutan in 2010 to that in 2012?
Offer a very short reply. 1.12. What is the ratio of the Mortality Rate (per 1000 live birth or children) of Germany in 2010 to that in 2012?
Your answer should be very brief. 1.05. What is the ratio of the Mortality Rate (per 1000 live birth or children) in Central Europe in 2010 to that in 2013?
Make the answer very short. 1.14. What is the ratio of the Mortality Rate (per 1000 live birth or children) in Bhutan in 2010 to that in 2013?
Provide a short and direct response. 1.18. What is the ratio of the Mortality Rate (per 1000 live birth or children) in Germany in 2010 to that in 2013?
Your response must be concise. 1.08. What is the ratio of the Mortality Rate (per 1000 live birth or children) in Central Europe in 2010 to that in 2014?
Offer a terse response. 1.18. What is the ratio of the Mortality Rate (per 1000 live birth or children) of Bhutan in 2010 to that in 2014?
Provide a short and direct response. 1.23. What is the ratio of the Mortality Rate (per 1000 live birth or children) of Germany in 2010 to that in 2014?
Ensure brevity in your answer.  1.11. What is the ratio of the Mortality Rate (per 1000 live birth or children) in Central Europe in 2010 to that in 2015?
Give a very brief answer. 1.21. What is the ratio of the Mortality Rate (per 1000 live birth or children) in Germany in 2010 to that in 2015?
Your response must be concise. 1.14. What is the ratio of the Mortality Rate (per 1000 live birth or children) in Central Europe in 2011 to that in 2012?
Your answer should be compact. 1.05. What is the ratio of the Mortality Rate (per 1000 live birth or children) in Bhutan in 2011 to that in 2012?
Your answer should be compact. 1.06. What is the ratio of the Mortality Rate (per 1000 live birth or children) of Germany in 2011 to that in 2012?
Your response must be concise. 1.02. What is the ratio of the Mortality Rate (per 1000 live birth or children) in Central Europe in 2011 to that in 2013?
Provide a short and direct response. 1.08. What is the ratio of the Mortality Rate (per 1000 live birth or children) in Bhutan in 2011 to that in 2013?
Keep it short and to the point. 1.11. What is the ratio of the Mortality Rate (per 1000 live birth or children) in Germany in 2011 to that in 2013?
Keep it short and to the point. 1.05. What is the ratio of the Mortality Rate (per 1000 live birth or children) in Central Europe in 2011 to that in 2014?
Offer a very short reply. 1.12. What is the ratio of the Mortality Rate (per 1000 live birth or children) of Bhutan in 2011 to that in 2014?
Offer a terse response. 1.16. What is the ratio of the Mortality Rate (per 1000 live birth or children) of Germany in 2011 to that in 2014?
Provide a succinct answer. 1.08. What is the ratio of the Mortality Rate (per 1000 live birth or children) of Central Europe in 2011 to that in 2015?
Ensure brevity in your answer.  1.14. What is the ratio of the Mortality Rate (per 1000 live birth or children) in Bhutan in 2011 to that in 2015?
Give a very brief answer. 1.21. What is the ratio of the Mortality Rate (per 1000 live birth or children) of Germany in 2011 to that in 2015?
Provide a succinct answer. 1.11. What is the ratio of the Mortality Rate (per 1000 live birth or children) in Central Europe in 2012 to that in 2013?
Offer a very short reply. 1.03. What is the ratio of the Mortality Rate (per 1000 live birth or children) in Bhutan in 2012 to that in 2013?
Your response must be concise. 1.05. What is the ratio of the Mortality Rate (per 1000 live birth or children) of Germany in 2012 to that in 2013?
Keep it short and to the point. 1.03. What is the ratio of the Mortality Rate (per 1000 live birth or children) of Central Europe in 2012 to that in 2014?
Keep it short and to the point. 1.07. What is the ratio of the Mortality Rate (per 1000 live birth or children) of Bhutan in 2012 to that in 2014?
Offer a very short reply. 1.1. What is the ratio of the Mortality Rate (per 1000 live birth or children) of Germany in 2012 to that in 2014?
Provide a short and direct response. 1.05. What is the ratio of the Mortality Rate (per 1000 live birth or children) of Central Europe in 2012 to that in 2015?
Your answer should be very brief. 1.09. What is the ratio of the Mortality Rate (per 1000 live birth or children) in Bhutan in 2012 to that in 2015?
Provide a succinct answer. 1.15. What is the ratio of the Mortality Rate (per 1000 live birth or children) of Germany in 2012 to that in 2015?
Keep it short and to the point. 1.08. What is the ratio of the Mortality Rate (per 1000 live birth or children) in Central Europe in 2013 to that in 2014?
Offer a terse response. 1.03. What is the ratio of the Mortality Rate (per 1000 live birth or children) in Bhutan in 2013 to that in 2014?
Your response must be concise. 1.05. What is the ratio of the Mortality Rate (per 1000 live birth or children) of Germany in 2013 to that in 2014?
Your response must be concise. 1.03. What is the ratio of the Mortality Rate (per 1000 live birth or children) of Central Europe in 2013 to that in 2015?
Make the answer very short. 1.06. What is the ratio of the Mortality Rate (per 1000 live birth or children) of Bhutan in 2013 to that in 2015?
Make the answer very short. 1.09. What is the ratio of the Mortality Rate (per 1000 live birth or children) of Germany in 2013 to that in 2015?
Your answer should be compact. 1.05. What is the ratio of the Mortality Rate (per 1000 live birth or children) of Central Europe in 2014 to that in 2015?
Your response must be concise. 1.03. What is the ratio of the Mortality Rate (per 1000 live birth or children) of Bhutan in 2014 to that in 2015?
Offer a very short reply. 1.05. What is the ratio of the Mortality Rate (per 1000 live birth or children) of Germany in 2014 to that in 2015?
Provide a short and direct response. 1.03. What is the difference between the highest and the second highest Mortality Rate (per 1000 live birth or children) in Central Europe?
Your answer should be compact. 0.61. What is the difference between the highest and the lowest Mortality Rate (per 1000 live birth or children) of Central Europe?
Give a very brief answer. 2.44. 